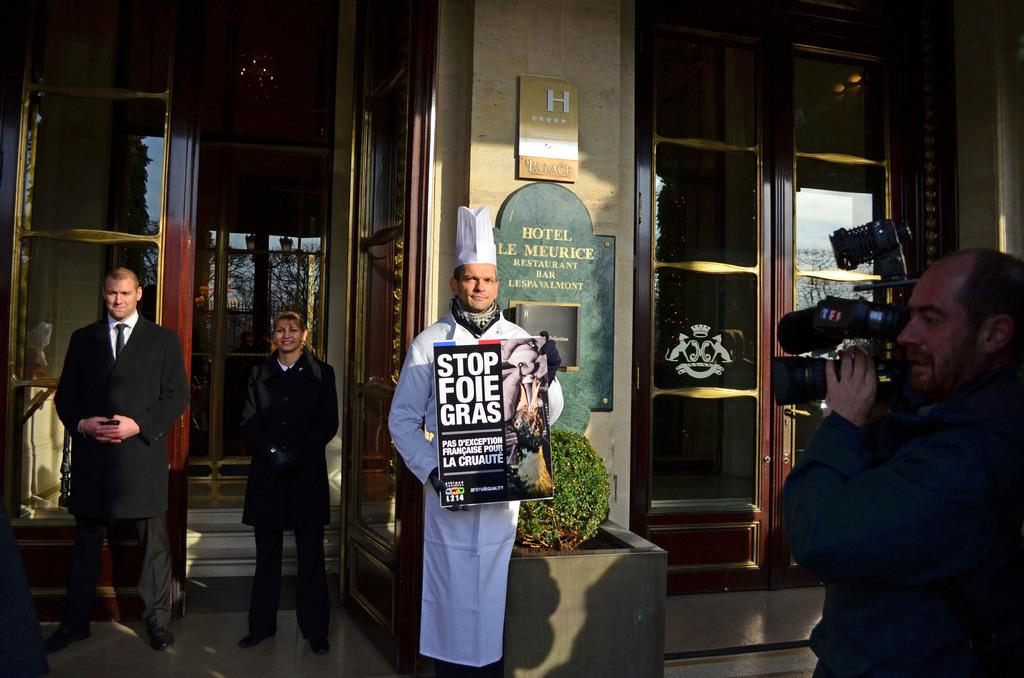How many people are in the image? There are persons standing in the image. What is the surface beneath the persons in the image? The persons are standing on a floor. What can be seen in the background of the image? There is a building in the background of the image. Where is the lake located in the image? There is no lake present in the image. What type of music is the band playing in the background? There is no band present in the image. 